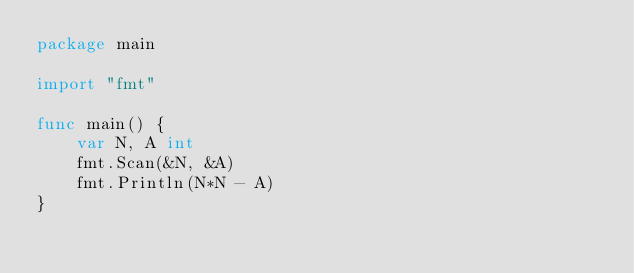Convert code to text. <code><loc_0><loc_0><loc_500><loc_500><_Go_>package main

import "fmt"

func main() {
	var N, A int
	fmt.Scan(&N, &A)
	fmt.Println(N*N - A)
}
</code> 